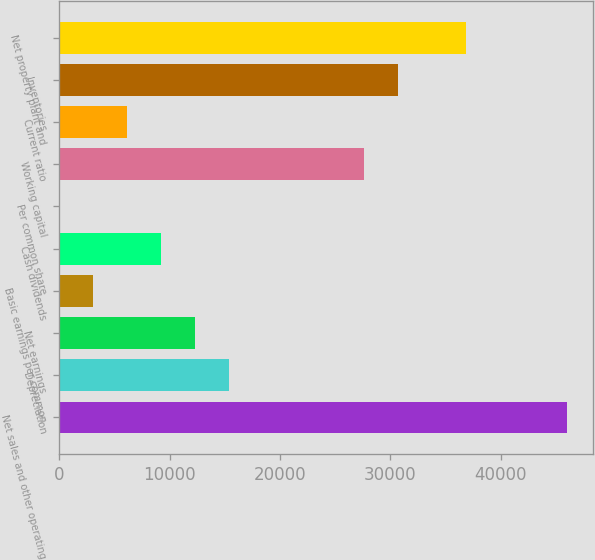Convert chart to OTSL. <chart><loc_0><loc_0><loc_500><loc_500><bar_chart><fcel>Net sales and other operating<fcel>Depreciation<fcel>Net earnings<fcel>Basic earnings per common<fcel>Cash dividends<fcel>Per common share<fcel>Working capital<fcel>Current ratio<fcel>Inventories<fcel>Net property plant and<nl><fcel>46061.9<fcel>15354.1<fcel>12283.4<fcel>3071.02<fcel>9212.58<fcel>0.24<fcel>27637.3<fcel>6141.8<fcel>30708<fcel>36849.6<nl></chart> 